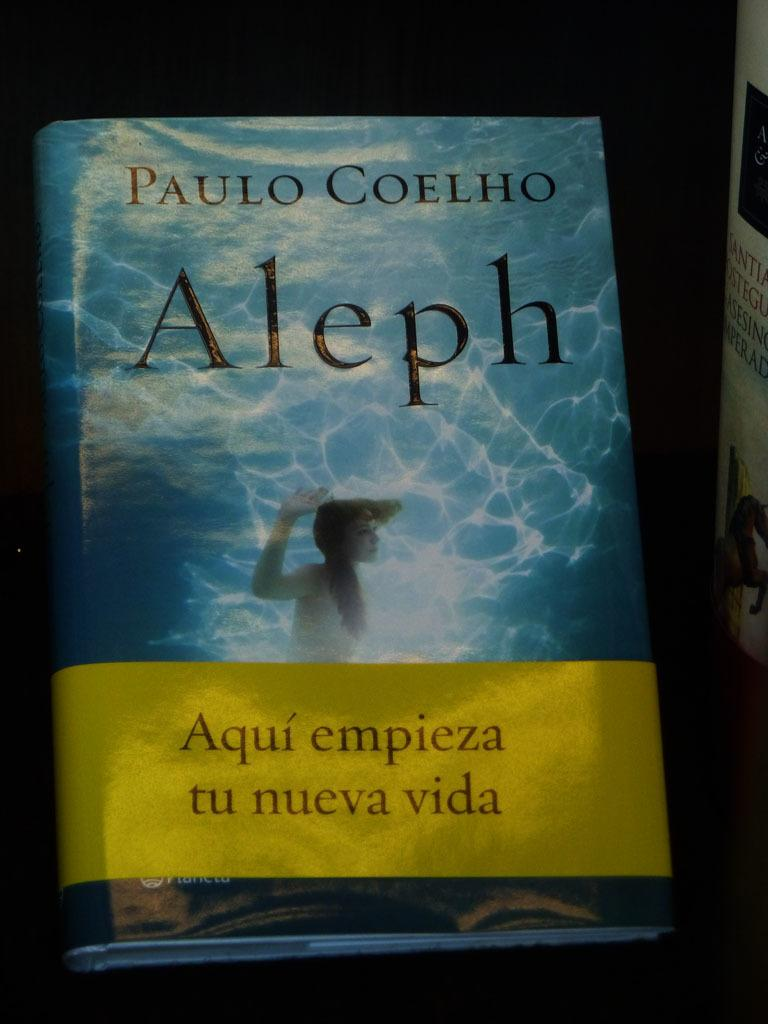Provide a one-sentence caption for the provided image. a book written in spanish with a cover of underwater. 